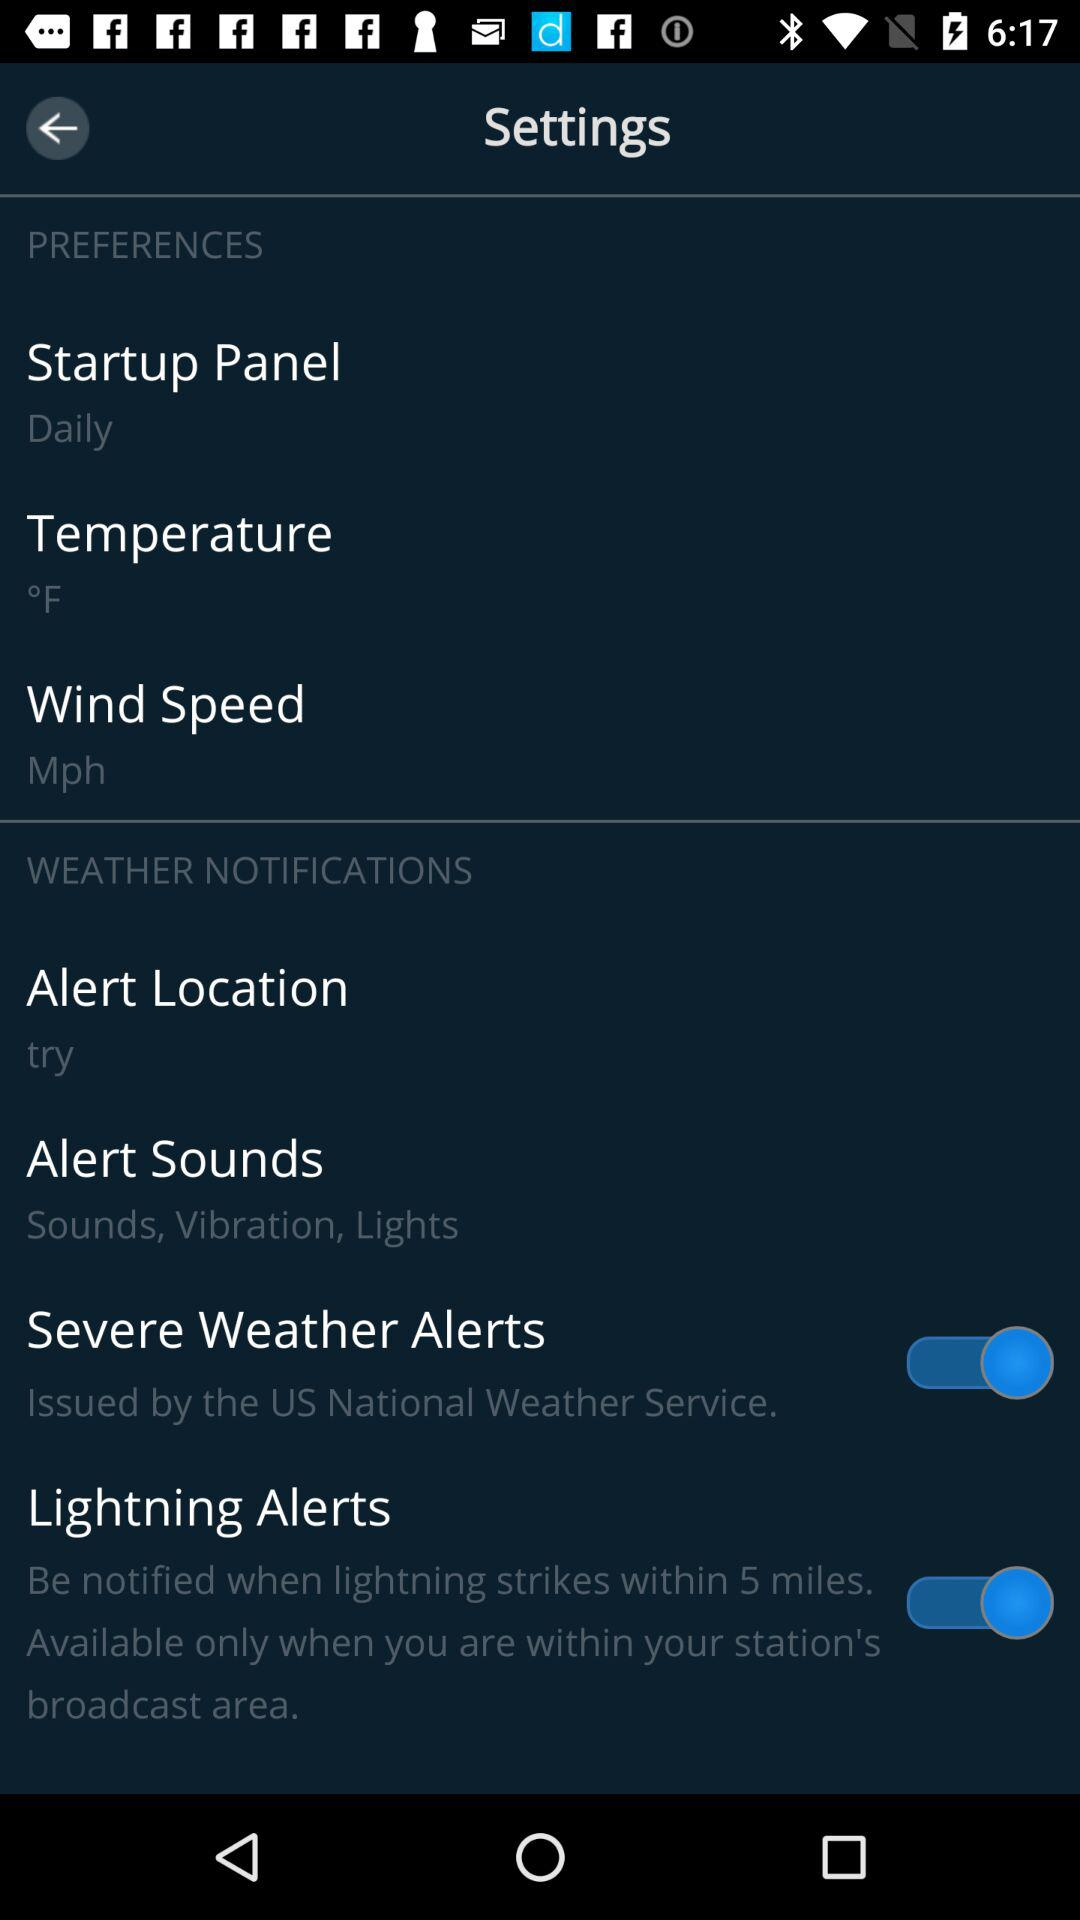What is the status of the "Severe Weather Alerts"? The status of the "Severe Weather Alerts" is "on". 